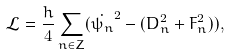Convert formula to latex. <formula><loc_0><loc_0><loc_500><loc_500>\mathcal { L } = \frac { h } { 4 } \sum _ { n \in { Z } } ( \dot { \psi _ { n } } ^ { 2 } - ( D _ { n } ^ { 2 } + F _ { n } ^ { 2 } ) ) ,</formula> 